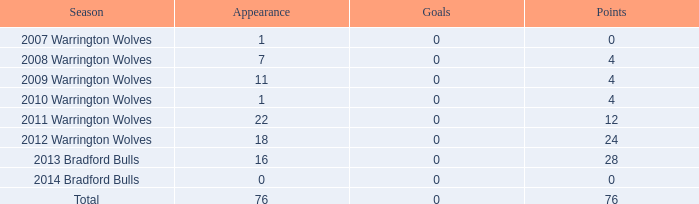Give me the full table as a dictionary. {'header': ['Season', 'Appearance', 'Goals', 'Points'], 'rows': [['2007 Warrington Wolves', '1', '0', '0'], ['2008 Warrington Wolves', '7', '0', '4'], ['2009 Warrington Wolves', '11', '0', '4'], ['2010 Warrington Wolves', '1', '0', '4'], ['2011 Warrington Wolves', '22', '0', '12'], ['2012 Warrington Wolves', '18', '0', '24'], ['2013 Bradford Bulls', '16', '0', '28'], ['2014 Bradford Bulls', '0', '0', '0'], ['Total', '76', '0', '76']]} What is the mean attempts for the 2008 warrington wolves season with over 7 appearances? None. 